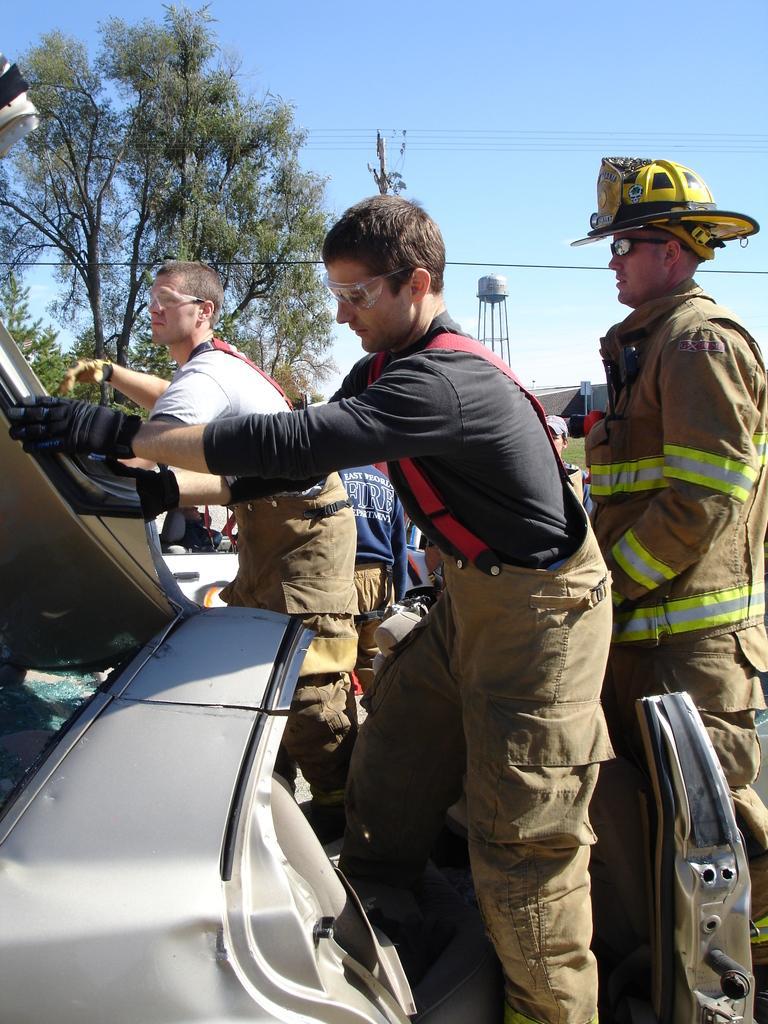Could you give a brief overview of what you see in this image? In the center of the image we can see some people are standing and holding the vehicle parts. In the background of the image we can see the trees, poles, wires, vehicles. At the top of the image we can see the sky. 